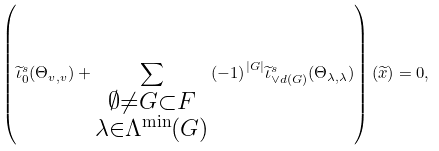Convert formula to latex. <formula><loc_0><loc_0><loc_500><loc_500>\left ( \widetilde { \iota } _ { 0 } ^ { s } ( \Theta _ { v , v } ) + \sum _ { \substack { \emptyset \not = G \subset F \\ \lambda \in \Lambda ^ { \min } ( G ) } } { ( - 1 ) } ^ { | G | } { \widetilde { \iota } } _ { \vee d ( G ) } ^ { s } ( \Theta _ { \lambda , \lambda } ) \right ) ( \widetilde { x } ) = 0 ,</formula> 